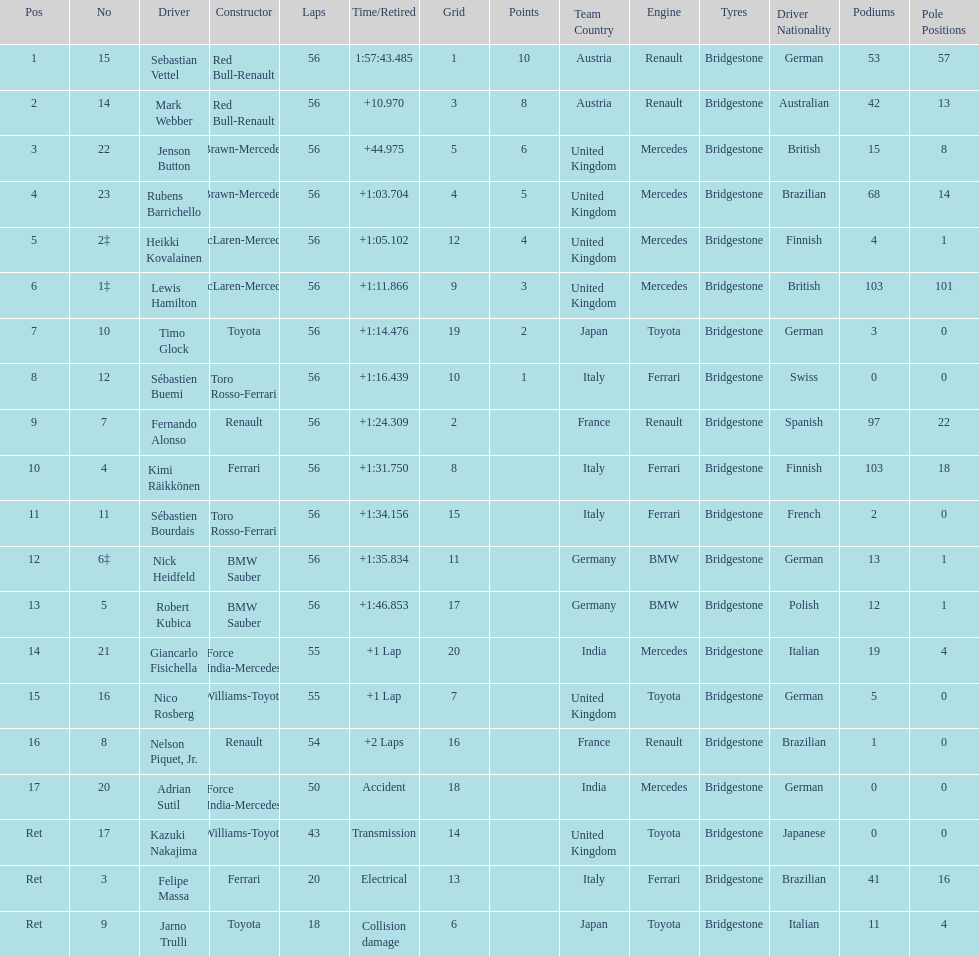Who are all of the drivers? Sebastian Vettel, Mark Webber, Jenson Button, Rubens Barrichello, Heikki Kovalainen, Lewis Hamilton, Timo Glock, Sébastien Buemi, Fernando Alonso, Kimi Räikkönen, Sébastien Bourdais, Nick Heidfeld, Robert Kubica, Giancarlo Fisichella, Nico Rosberg, Nelson Piquet, Jr., Adrian Sutil, Kazuki Nakajima, Felipe Massa, Jarno Trulli. Who were their constructors? Red Bull-Renault, Red Bull-Renault, Brawn-Mercedes, Brawn-Mercedes, McLaren-Mercedes, McLaren-Mercedes, Toyota, Toro Rosso-Ferrari, Renault, Ferrari, Toro Rosso-Ferrari, BMW Sauber, BMW Sauber, Force India-Mercedes, Williams-Toyota, Renault, Force India-Mercedes, Williams-Toyota, Ferrari, Toyota. Who was the first listed driver to not drive a ferrari?? Sebastian Vettel. 